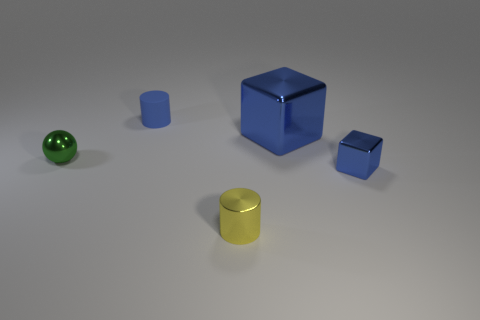There is a big thing that is the same color as the small rubber thing; what material is it?
Offer a very short reply. Metal. Are there the same number of small yellow cylinders that are to the right of the metallic cylinder and small matte things?
Ensure brevity in your answer.  No. There is a big blue block; are there any things on the right side of it?
Provide a short and direct response. Yes. How many rubber objects are big objects or red objects?
Make the answer very short. 0. How many blue rubber cylinders are behind the ball?
Ensure brevity in your answer.  1. Is there a green metal cube that has the same size as the green metallic ball?
Make the answer very short. No. Is there a small shiny block of the same color as the metal cylinder?
Offer a very short reply. No. What number of small shiny cylinders have the same color as the large thing?
Your answer should be compact. 0. There is a large cube; is its color the same as the cylinder in front of the tiny blue shiny cube?
Provide a short and direct response. No. What number of things are cylinders or blue shiny blocks in front of the green metal ball?
Make the answer very short. 3. 